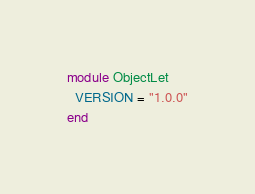<code> <loc_0><loc_0><loc_500><loc_500><_Ruby_>module ObjectLet
  VERSION = "1.0.0"
end
</code> 